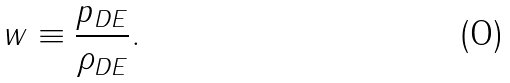<formula> <loc_0><loc_0><loc_500><loc_500>w \equiv \frac { p _ { D E } } { \rho _ { D E } } .</formula> 